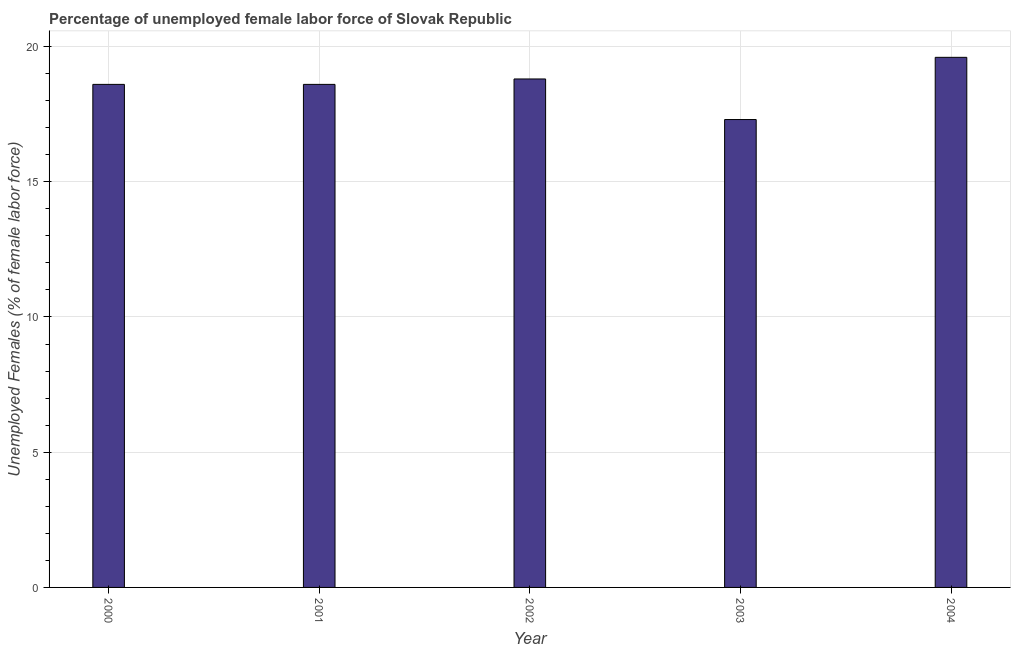Does the graph contain any zero values?
Give a very brief answer. No. Does the graph contain grids?
Provide a succinct answer. Yes. What is the title of the graph?
Give a very brief answer. Percentage of unemployed female labor force of Slovak Republic. What is the label or title of the Y-axis?
Your response must be concise. Unemployed Females (% of female labor force). What is the total unemployed female labour force in 2004?
Ensure brevity in your answer.  19.6. Across all years, what is the maximum total unemployed female labour force?
Provide a short and direct response. 19.6. Across all years, what is the minimum total unemployed female labour force?
Ensure brevity in your answer.  17.3. In which year was the total unemployed female labour force maximum?
Your response must be concise. 2004. In which year was the total unemployed female labour force minimum?
Your answer should be very brief. 2003. What is the sum of the total unemployed female labour force?
Make the answer very short. 92.9. What is the average total unemployed female labour force per year?
Your answer should be very brief. 18.58. What is the median total unemployed female labour force?
Offer a terse response. 18.6. What is the ratio of the total unemployed female labour force in 2000 to that in 2001?
Ensure brevity in your answer.  1. Is the total unemployed female labour force in 2002 less than that in 2003?
Offer a very short reply. No. What is the difference between the highest and the second highest total unemployed female labour force?
Keep it short and to the point. 0.8. Are the values on the major ticks of Y-axis written in scientific E-notation?
Offer a terse response. No. What is the Unemployed Females (% of female labor force) of 2000?
Provide a succinct answer. 18.6. What is the Unemployed Females (% of female labor force) of 2001?
Provide a succinct answer. 18.6. What is the Unemployed Females (% of female labor force) in 2002?
Make the answer very short. 18.8. What is the Unemployed Females (% of female labor force) of 2003?
Offer a terse response. 17.3. What is the Unemployed Females (% of female labor force) in 2004?
Give a very brief answer. 19.6. What is the difference between the Unemployed Females (% of female labor force) in 2000 and 2001?
Your answer should be very brief. 0. What is the difference between the Unemployed Females (% of female labor force) in 2000 and 2002?
Your answer should be very brief. -0.2. What is the difference between the Unemployed Females (% of female labor force) in 2000 and 2003?
Offer a very short reply. 1.3. What is the difference between the Unemployed Females (% of female labor force) in 2001 and 2002?
Give a very brief answer. -0.2. What is the difference between the Unemployed Females (% of female labor force) in 2001 and 2004?
Keep it short and to the point. -1. What is the difference between the Unemployed Females (% of female labor force) in 2002 and 2004?
Offer a terse response. -0.8. What is the difference between the Unemployed Females (% of female labor force) in 2003 and 2004?
Make the answer very short. -2.3. What is the ratio of the Unemployed Females (% of female labor force) in 2000 to that in 2003?
Give a very brief answer. 1.07. What is the ratio of the Unemployed Females (% of female labor force) in 2000 to that in 2004?
Your answer should be compact. 0.95. What is the ratio of the Unemployed Females (% of female labor force) in 2001 to that in 2003?
Your response must be concise. 1.07. What is the ratio of the Unemployed Females (% of female labor force) in 2001 to that in 2004?
Your answer should be very brief. 0.95. What is the ratio of the Unemployed Females (% of female labor force) in 2002 to that in 2003?
Your answer should be very brief. 1.09. What is the ratio of the Unemployed Females (% of female labor force) in 2002 to that in 2004?
Make the answer very short. 0.96. What is the ratio of the Unemployed Females (% of female labor force) in 2003 to that in 2004?
Offer a very short reply. 0.88. 